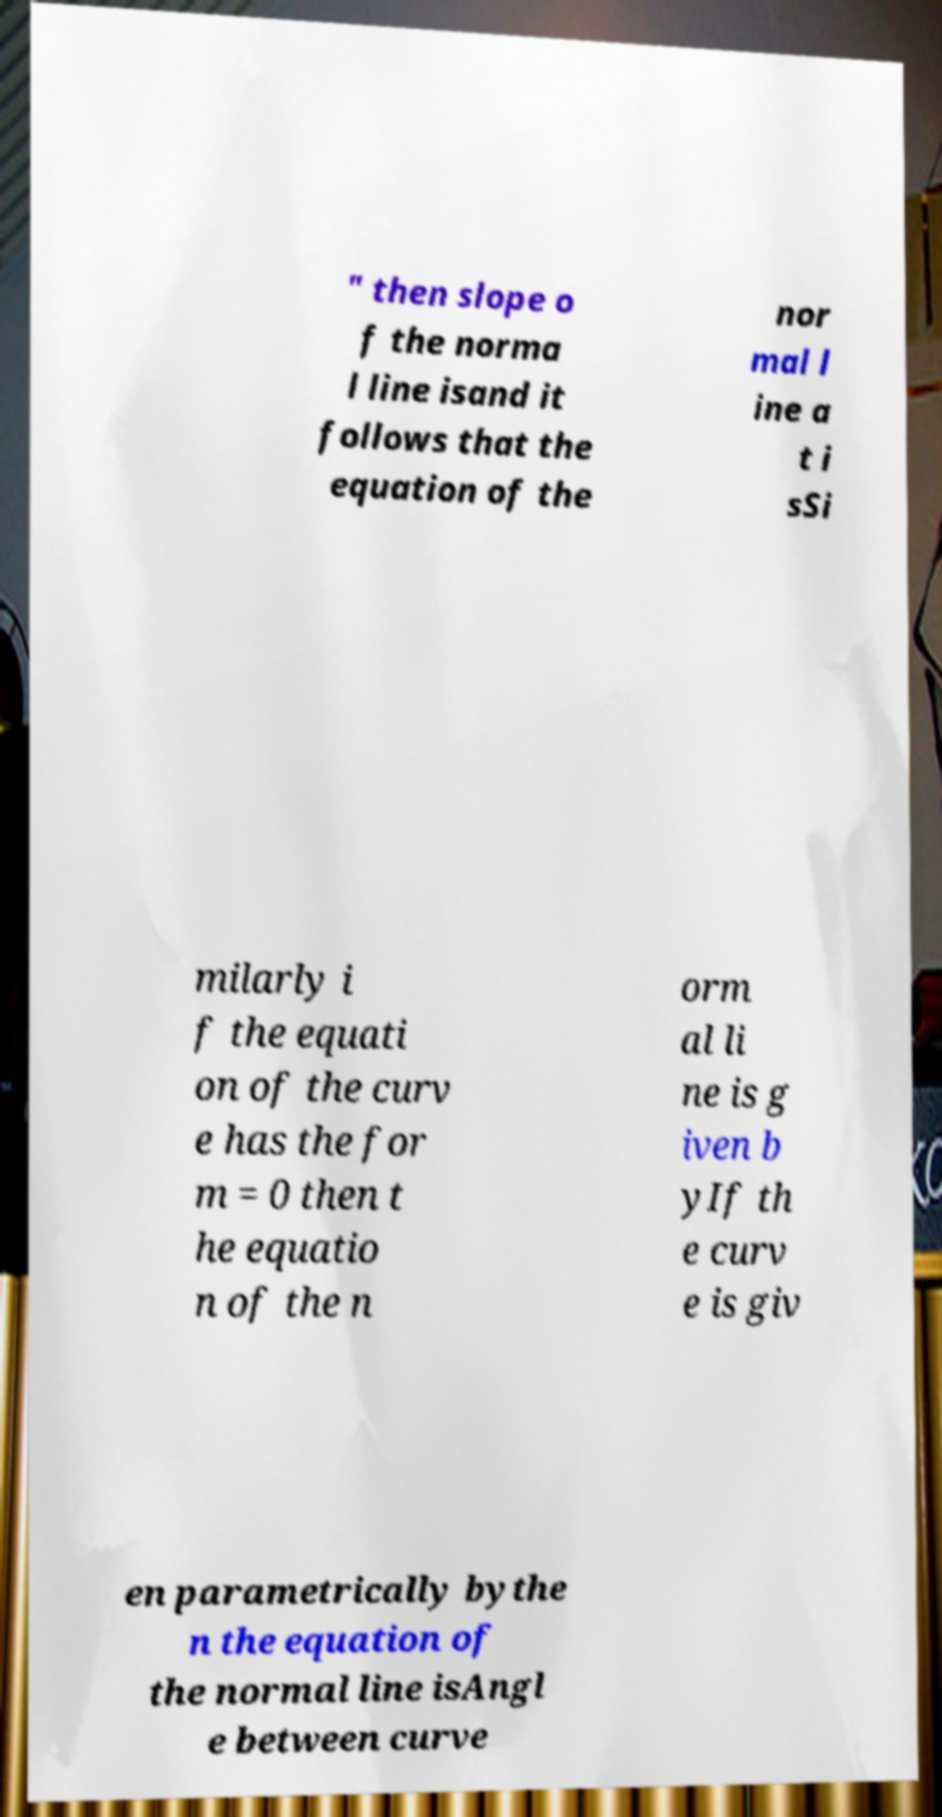There's text embedded in this image that I need extracted. Can you transcribe it verbatim? The text in the image seems to relate to mathematical principles concerning the slopes of curves and their corresponding normal lines. The visible parts read: 'then slope of the normal line is and it follows that the equation of the normal line at is Similarly if the equation of the curve has the form = 0 then the equation of the normal line is given by If the curve is given parametrically by then the equation of the normal line is Angle between curve.' Please note that due to the distorted and incomplete visibility of the text, the exact transcription might slightly deviate. 